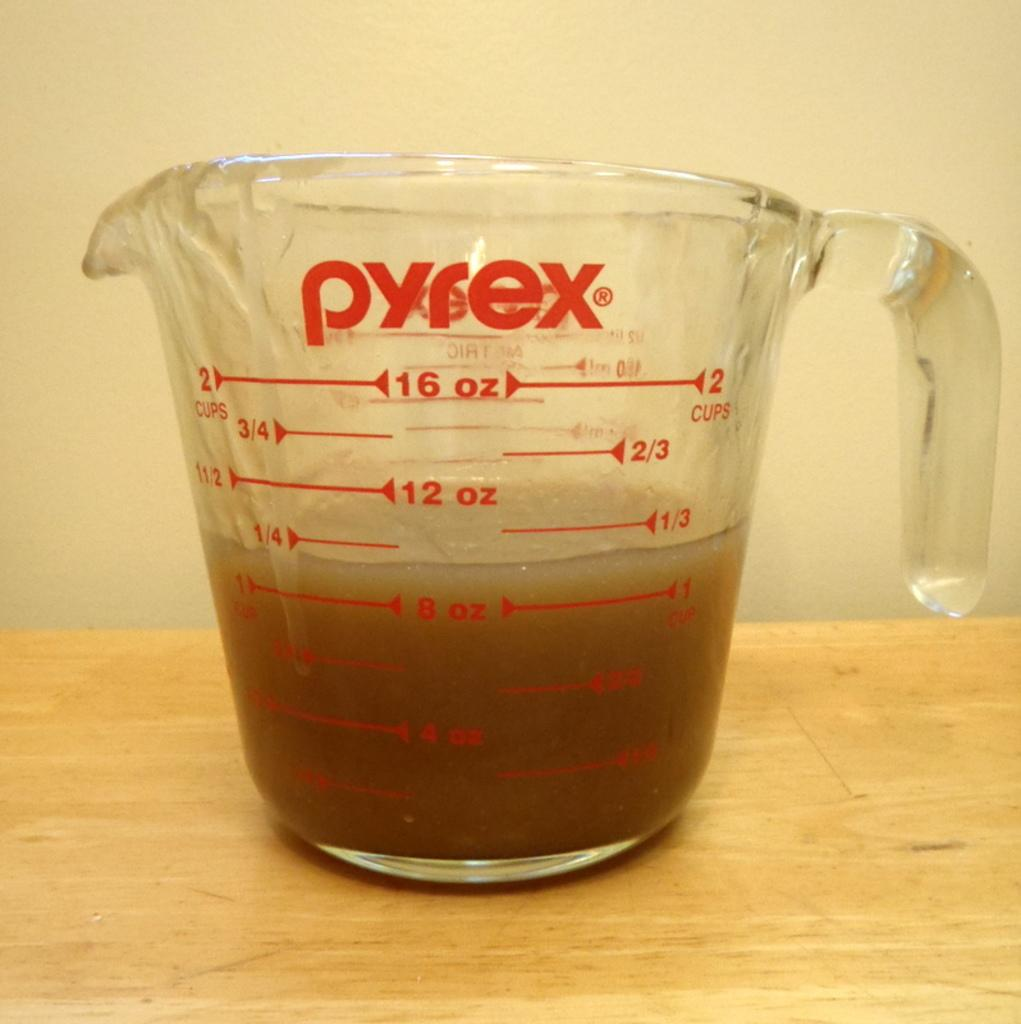What is present in the image? There is a cup in the image. What is inside the cup? The cup contains something. What type of surface is the cup placed on? The wooden table is present in the image. How does the trick work in the image? There is no trick present in the image; it simply shows a cup on a wooden table. 